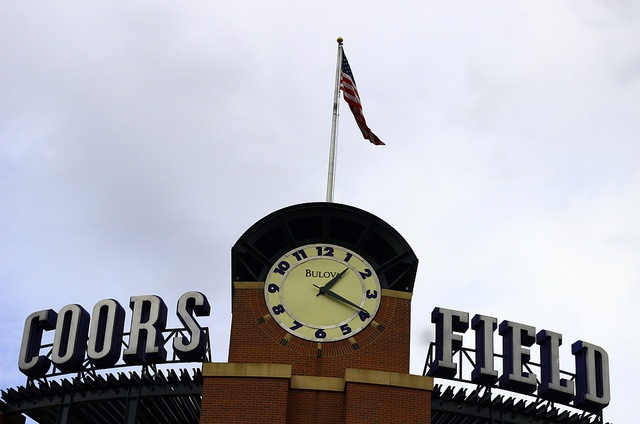Describe the objects in this image and their specific colors. I can see a clock in lavender, olive, black, darkgray, and gray tones in this image. 